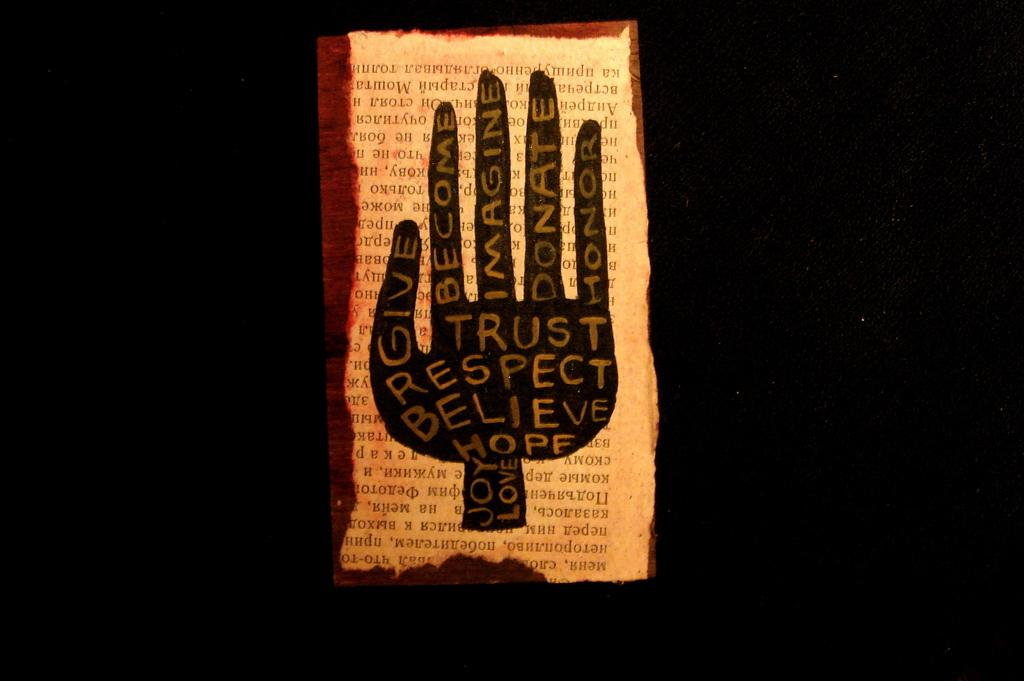<image>
Create a compact narrative representing the image presented. a poster with the words respect, trust, become, imagine on it 